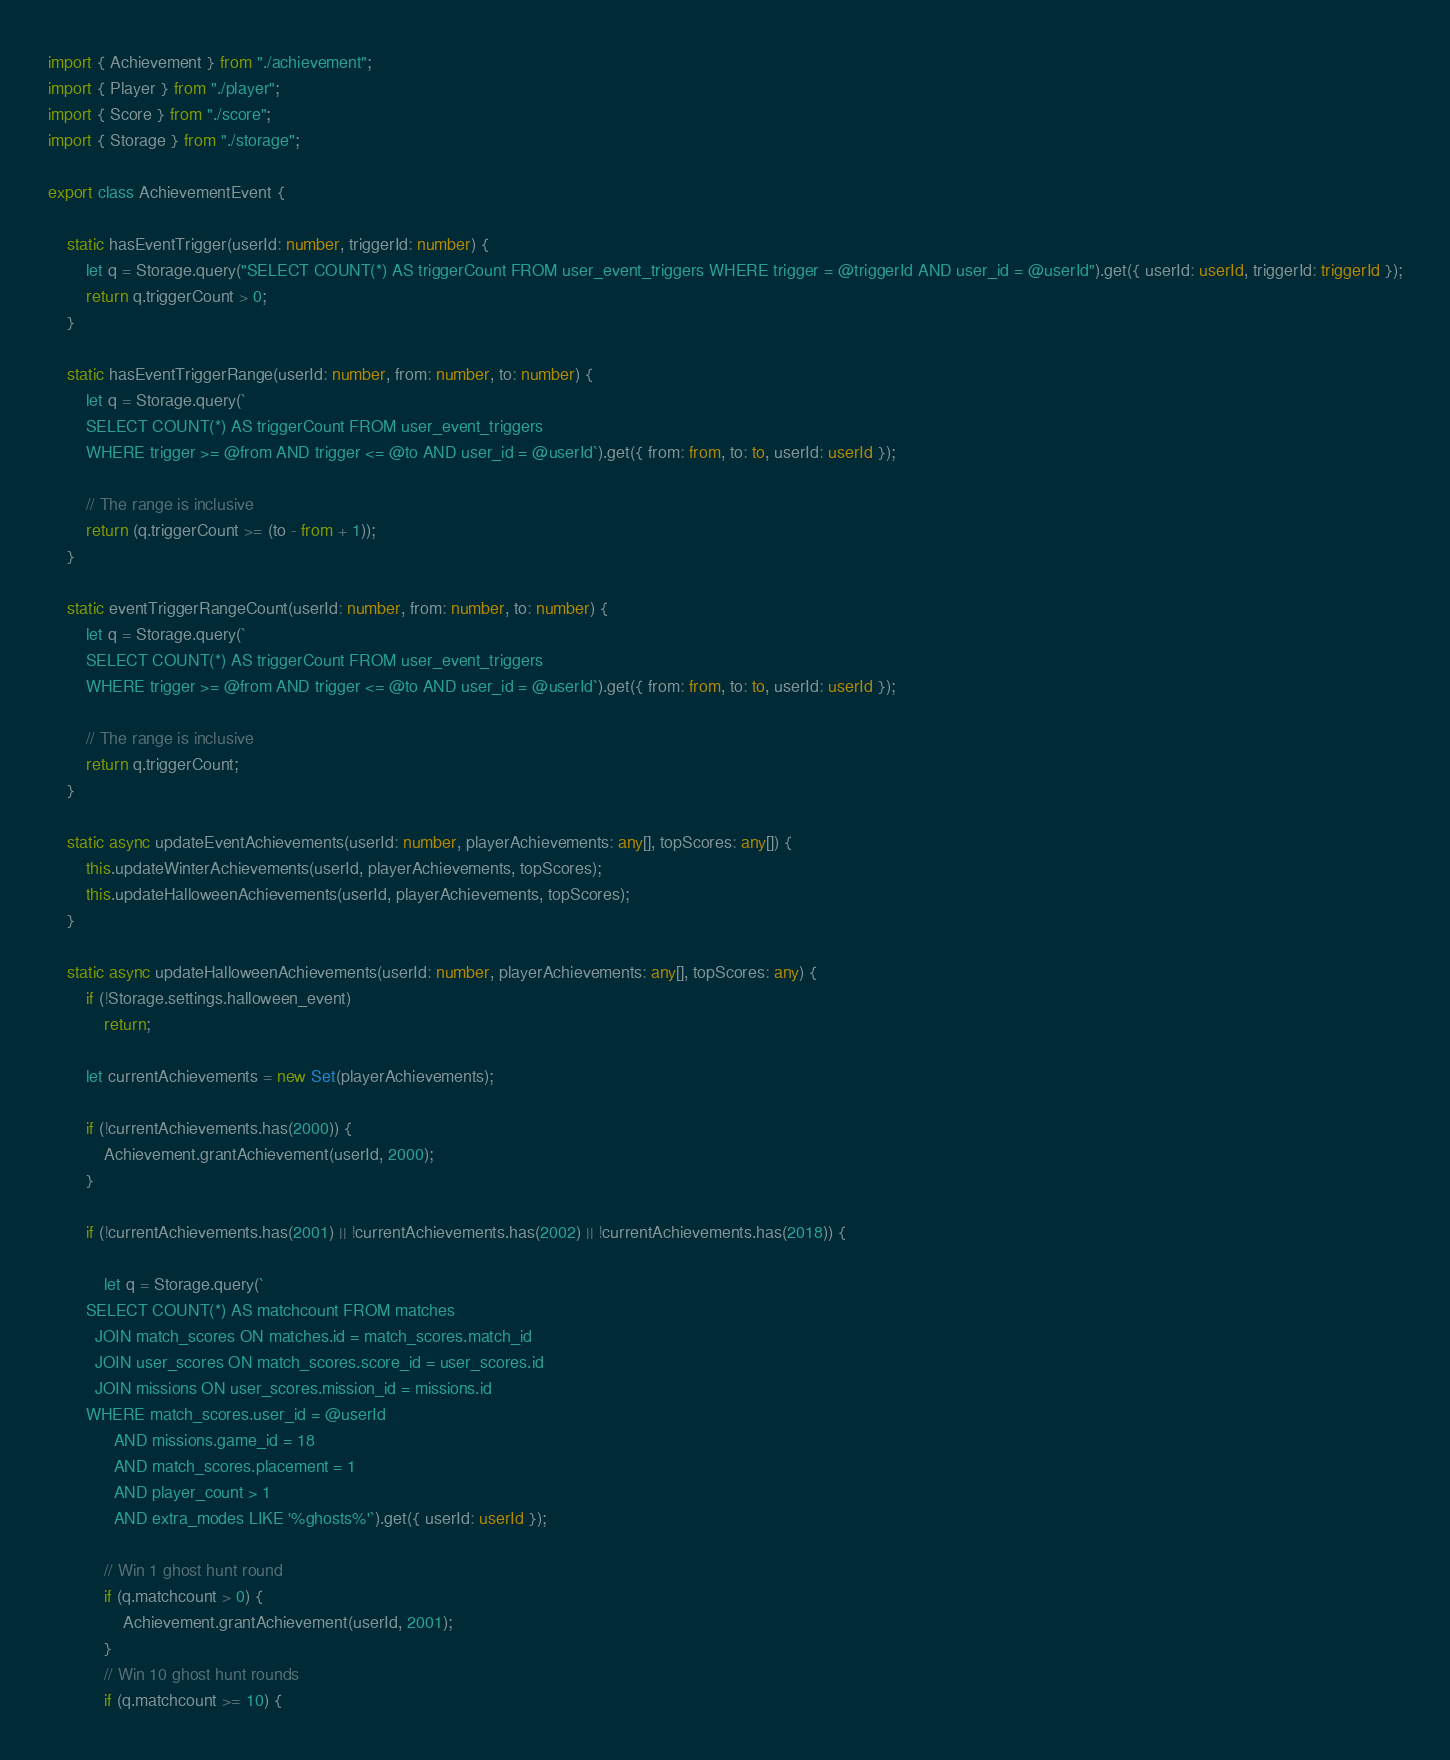<code> <loc_0><loc_0><loc_500><loc_500><_TypeScript_>import { Achievement } from "./achievement";
import { Player } from "./player";
import { Score } from "./score";
import { Storage } from "./storage";

export class AchievementEvent {

    static hasEventTrigger(userId: number, triggerId: number) {
        let q = Storage.query("SELECT COUNT(*) AS triggerCount FROM user_event_triggers WHERE trigger = @triggerId AND user_id = @userId").get({ userId: userId, triggerId: triggerId });
        return q.triggerCount > 0;
    }

    static hasEventTriggerRange(userId: number, from: number, to: number) {
        let q = Storage.query(`
        SELECT COUNT(*) AS triggerCount FROM user_event_triggers
        WHERE trigger >= @from AND trigger <= @to AND user_id = @userId`).get({ from: from, to: to, userId: userId });

        // The range is inclusive
        return (q.triggerCount >= (to - from + 1));
    }

    static eventTriggerRangeCount(userId: number, from: number, to: number) {
        let q = Storage.query(`
        SELECT COUNT(*) AS triggerCount FROM user_event_triggers
        WHERE trigger >= @from AND trigger <= @to AND user_id = @userId`).get({ from: from, to: to, userId: userId });

        // The range is inclusive
        return q.triggerCount;
    }

    static async updateEventAchievements(userId: number, playerAchievements: any[], topScores: any[]) {
        this.updateWinterAchievements(userId, playerAchievements, topScores);
        this.updateHalloweenAchievements(userId, playerAchievements, topScores);
    }

    static async updateHalloweenAchievements(userId: number, playerAchievements: any[], topScores: any) {
        if (!Storage.settings.halloween_event)
            return;
        
        let currentAchievements = new Set(playerAchievements);
        
        if (!currentAchievements.has(2000)) {
            Achievement.grantAchievement(userId, 2000);
        }

        if (!currentAchievements.has(2001) || !currentAchievements.has(2002) || !currentAchievements.has(2018)) {

            let q = Storage.query(`
        SELECT COUNT(*) AS matchcount FROM matches
          JOIN match_scores ON matches.id = match_scores.match_id
          JOIN user_scores ON match_scores.score_id = user_scores.id
          JOIN missions ON user_scores.mission_id = missions.id
        WHERE match_scores.user_id = @userId
              AND missions.game_id = 18
              AND match_scores.placement = 1
              AND player_count > 1
              AND extra_modes LIKE '%ghosts%'`).get({ userId: userId });
        
            // Win 1 ghost hunt round
            if (q.matchcount > 0) {
                Achievement.grantAchievement(userId, 2001);
            }
            // Win 10 ghost hunt rounds
            if (q.matchcount >= 10) {</code> 